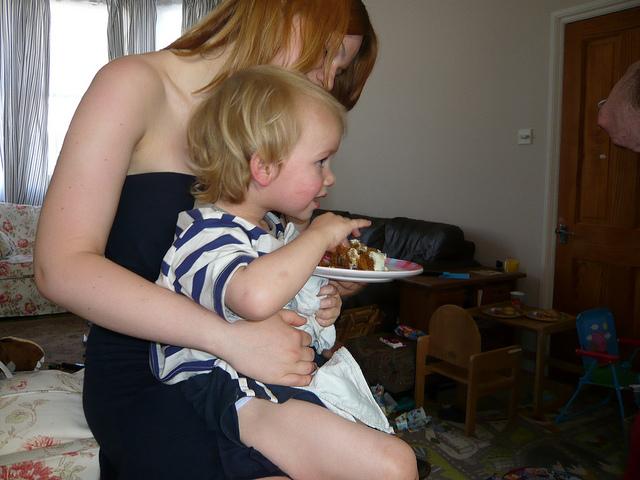What food is he eating?
Quick response, please. Cake. What kind of cake is the baby eating?
Answer briefly. Carrot cake. Is the child eating?
Keep it brief. Yes. Are there little figurines on top of the cake?
Quick response, please. No. What color dresses are the mom and baby wearing?
Write a very short answer. Black. What is the boy doing?
Be succinct. Eating. Is the door open?
Quick response, please. No. What room is the girl in?
Keep it brief. Living room. What are the children doing?
Short answer required. Eating. Is the baby with his daddy?
Write a very short answer. No. What color is the woman's dress?
Concise answer only. Black. Where is the child sitting?
Answer briefly. Lap. What is the woman doing to the child?
Quick response, please. Holding. What is the name of the pattern of the girl's dress?
Answer briefly. Stripes. What is the boy holding?
Short answer required. Plate. What season do you think this picture was taken in?
Short answer required. Summer. Is the child looking at the woman?
Write a very short answer. No. How many bananas does the boy have?
Keep it brief. 0. What is the little boy having done?
Answer briefly. Eating. Is the curtain closed?
Answer briefly. No. What is the woman holding?
Short answer required. Baby. What pattern is on the girl's shirt?
Quick response, please. Stripes. Is she being taught?
Quick response, please. No. What is the color of the women's hair?
Give a very brief answer. Red. What is the mother holding in her hands?
Keep it brief. Child. 